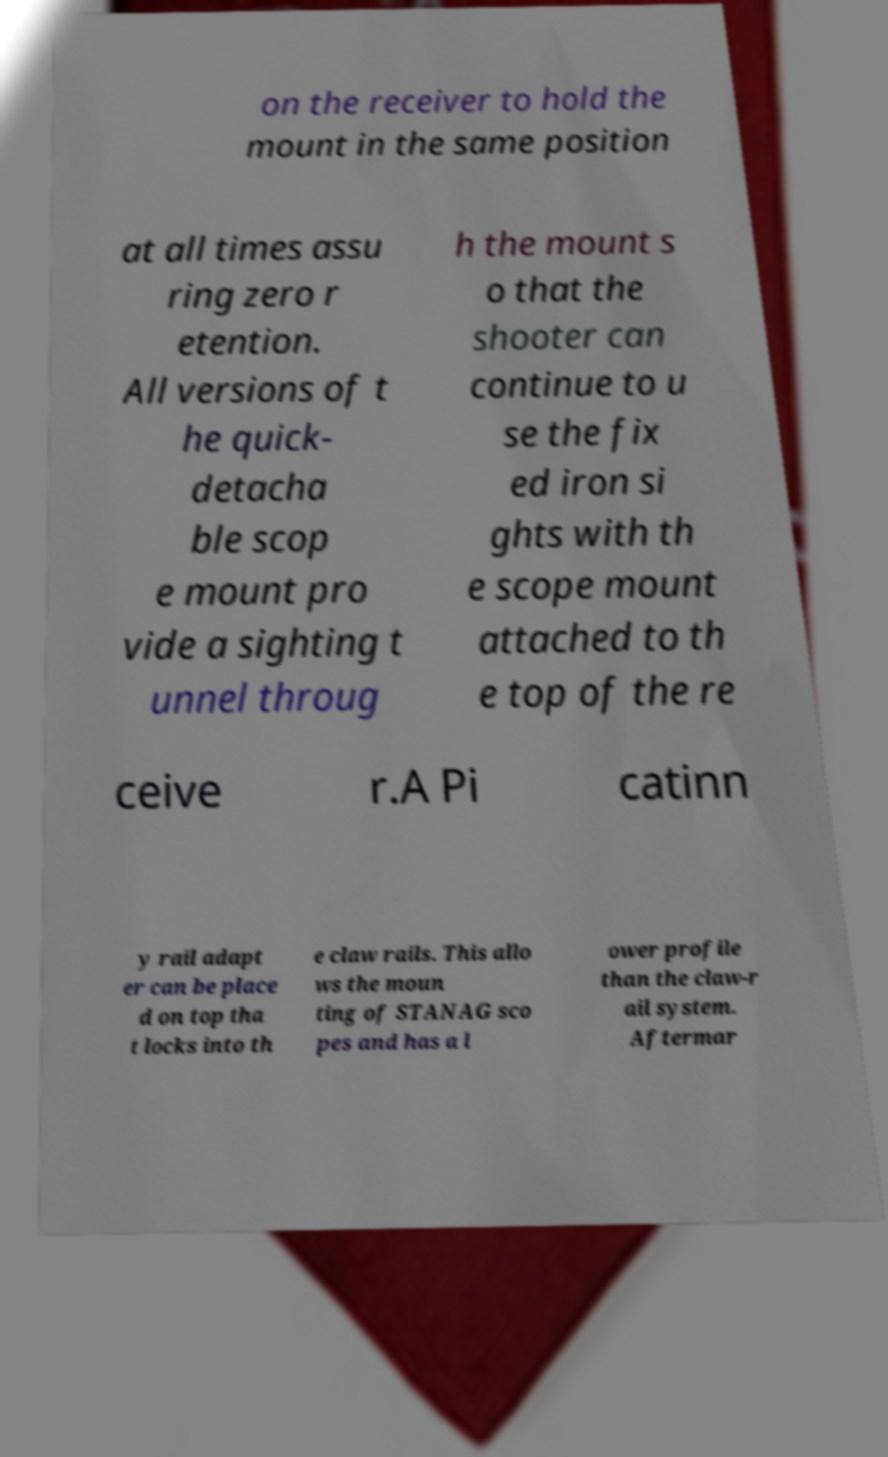Please read and relay the text visible in this image. What does it say? on the receiver to hold the mount in the same position at all times assu ring zero r etention. All versions of t he quick- detacha ble scop e mount pro vide a sighting t unnel throug h the mount s o that the shooter can continue to u se the fix ed iron si ghts with th e scope mount attached to th e top of the re ceive r.A Pi catinn y rail adapt er can be place d on top tha t locks into th e claw rails. This allo ws the moun ting of STANAG sco pes and has a l ower profile than the claw-r ail system. Aftermar 